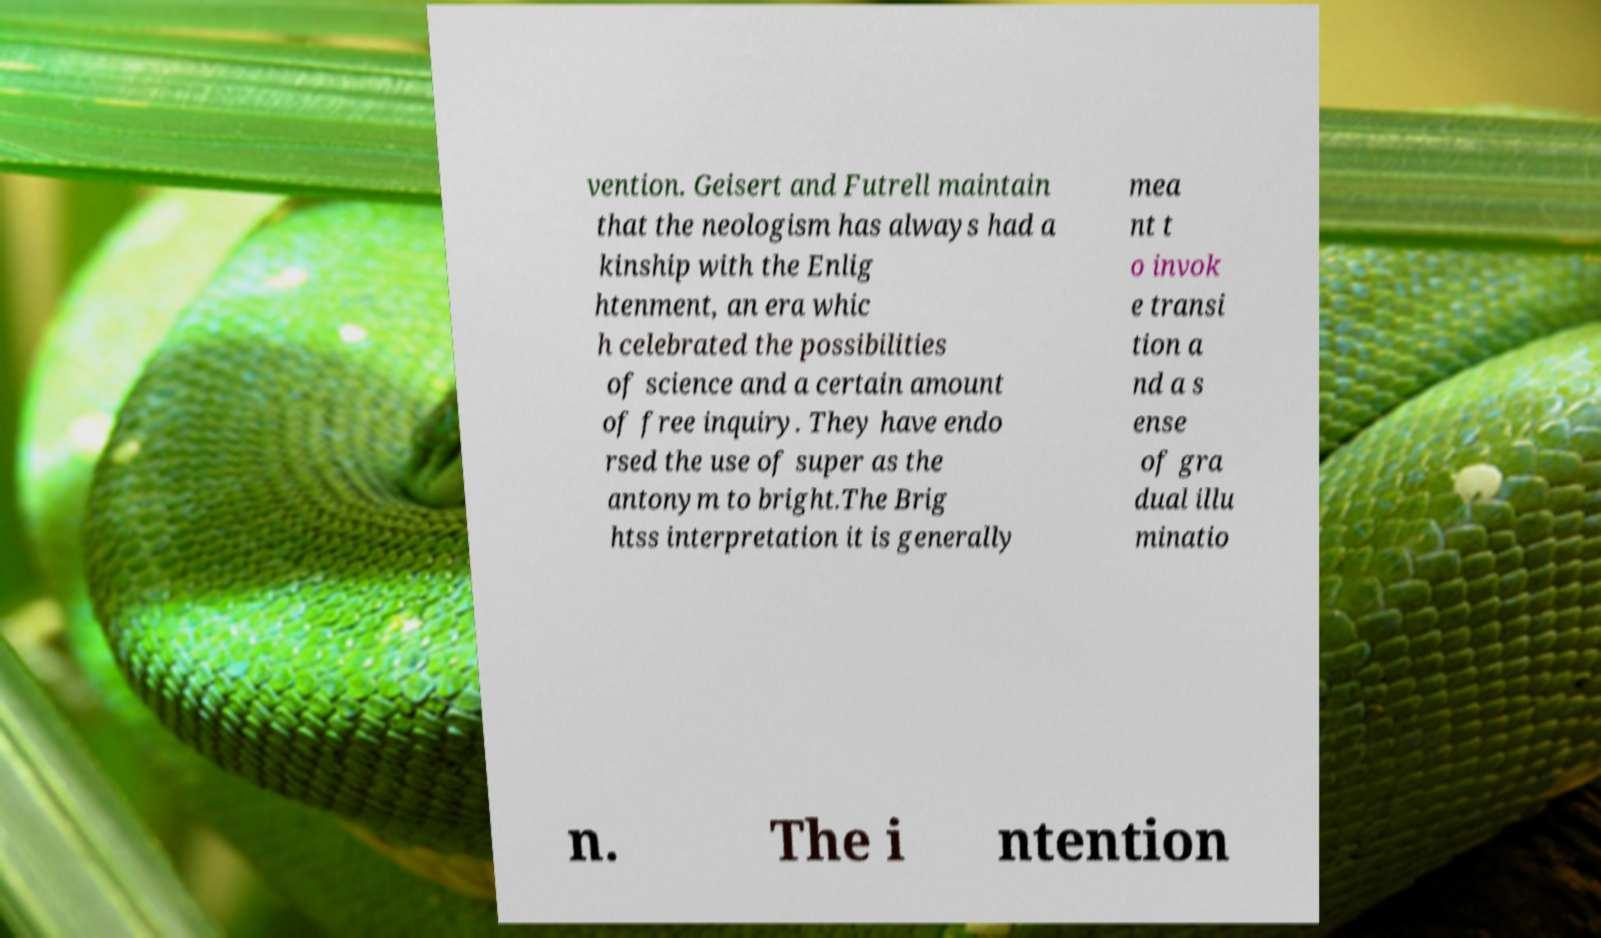I need the written content from this picture converted into text. Can you do that? vention. Geisert and Futrell maintain that the neologism has always had a kinship with the Enlig htenment, an era whic h celebrated the possibilities of science and a certain amount of free inquiry. They have endo rsed the use of super as the antonym to bright.The Brig htss interpretation it is generally mea nt t o invok e transi tion a nd a s ense of gra dual illu minatio n. The i ntention 